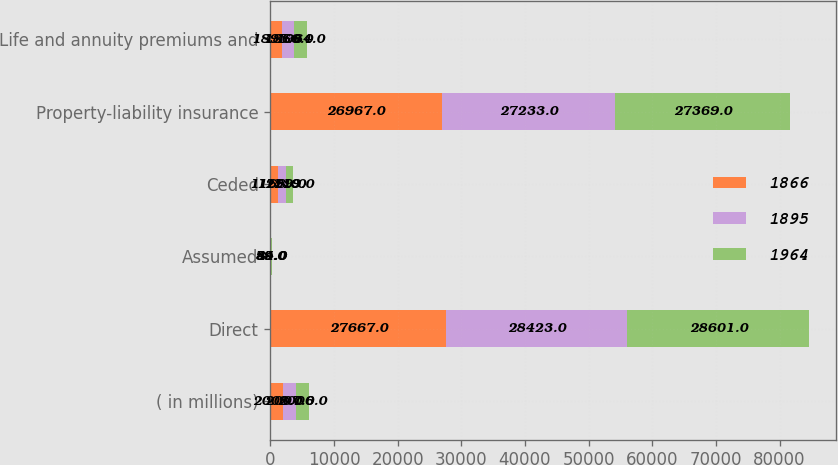Convert chart. <chart><loc_0><loc_0><loc_500><loc_500><stacked_bar_chart><ecel><fcel>( in millions)<fcel>Direct<fcel>Assumed<fcel>Ceded<fcel>Property-liability insurance<fcel>Life and annuity premiums and<nl><fcel>1866<fcel>2008<fcel>27667<fcel>85<fcel>1168<fcel>26967<fcel>1895<nl><fcel>1895<fcel>2007<fcel>28423<fcel>59<fcel>1299<fcel>27233<fcel>1866<nl><fcel>1964<fcel>2006<fcel>28601<fcel>44<fcel>1119<fcel>27369<fcel>1964<nl></chart> 